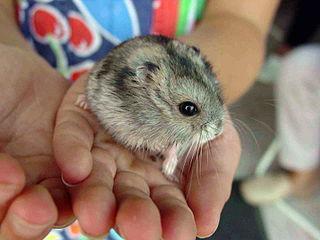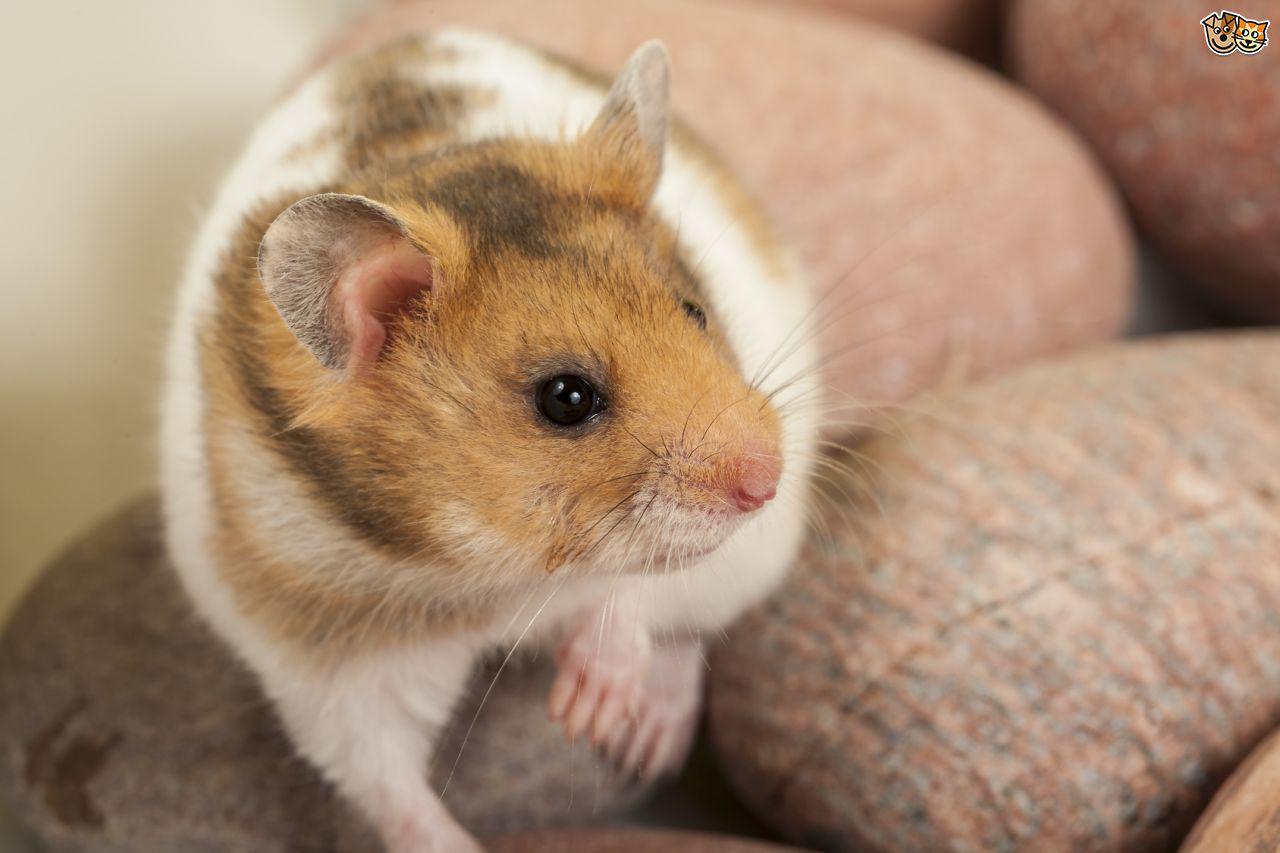The first image is the image on the left, the second image is the image on the right. Given the left and right images, does the statement "Cupped hands hold at least one pet rodent in one image." hold true? Answer yes or no. Yes. The first image is the image on the left, the second image is the image on the right. For the images shown, is this caption "There are two pairs of hamsters" true? Answer yes or no. No. 